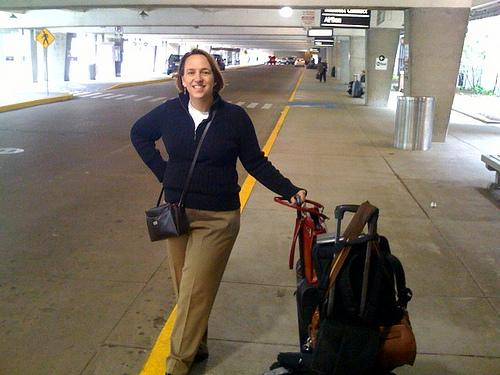What is she doing? Please explain your reasoning. posing. She is standing still and smiling for the camera. 